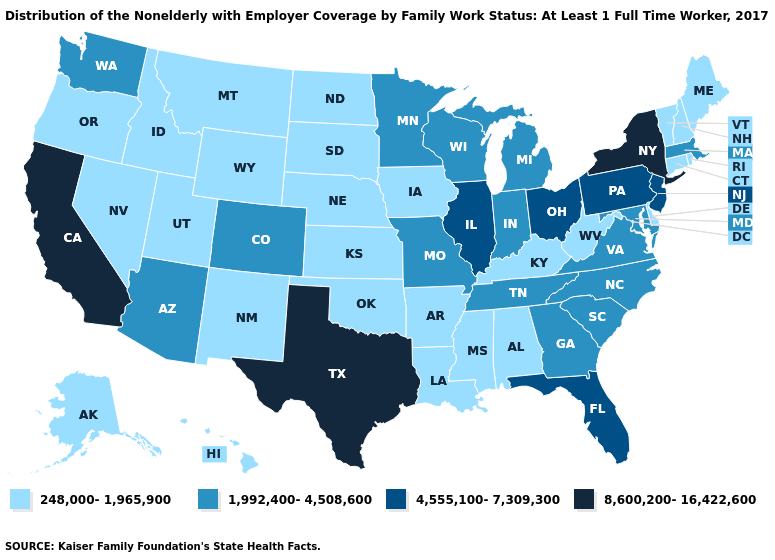Name the states that have a value in the range 8,600,200-16,422,600?
Write a very short answer. California, New York, Texas. Does Georgia have the lowest value in the USA?
Quick response, please. No. Among the states that border Texas , which have the lowest value?
Write a very short answer. Arkansas, Louisiana, New Mexico, Oklahoma. Does the first symbol in the legend represent the smallest category?
Write a very short answer. Yes. Name the states that have a value in the range 4,555,100-7,309,300?
Answer briefly. Florida, Illinois, New Jersey, Ohio, Pennsylvania. What is the value of Wyoming?
Be succinct. 248,000-1,965,900. What is the highest value in the South ?
Write a very short answer. 8,600,200-16,422,600. Name the states that have a value in the range 248,000-1,965,900?
Short answer required. Alabama, Alaska, Arkansas, Connecticut, Delaware, Hawaii, Idaho, Iowa, Kansas, Kentucky, Louisiana, Maine, Mississippi, Montana, Nebraska, Nevada, New Hampshire, New Mexico, North Dakota, Oklahoma, Oregon, Rhode Island, South Dakota, Utah, Vermont, West Virginia, Wyoming. Does the first symbol in the legend represent the smallest category?
Short answer required. Yes. Does Pennsylvania have the lowest value in the USA?
Short answer required. No. What is the lowest value in the USA?
Quick response, please. 248,000-1,965,900. What is the value of Arkansas?
Write a very short answer. 248,000-1,965,900. Among the states that border Colorado , which have the lowest value?
Keep it brief. Kansas, Nebraska, New Mexico, Oklahoma, Utah, Wyoming. What is the value of New Jersey?
Concise answer only. 4,555,100-7,309,300. Does New Hampshire have the lowest value in the Northeast?
Concise answer only. Yes. 